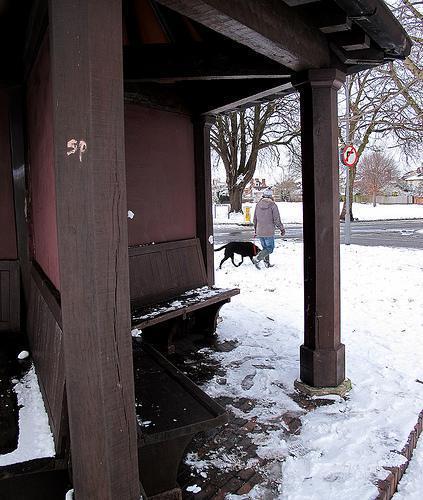How many benches are there?
Give a very brief answer. 3. 